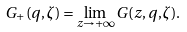Convert formula to latex. <formula><loc_0><loc_0><loc_500><loc_500>G _ { + } ( q , \zeta ) = \lim _ { z \to + \infty } G ( z , q , \zeta ) .</formula> 